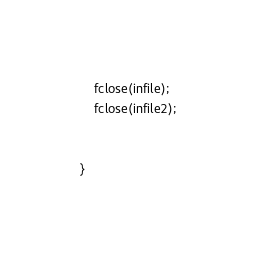<code> <loc_0><loc_0><loc_500><loc_500><_C_>
	fclose(infile);
	fclose(infile2);


}
</code> 